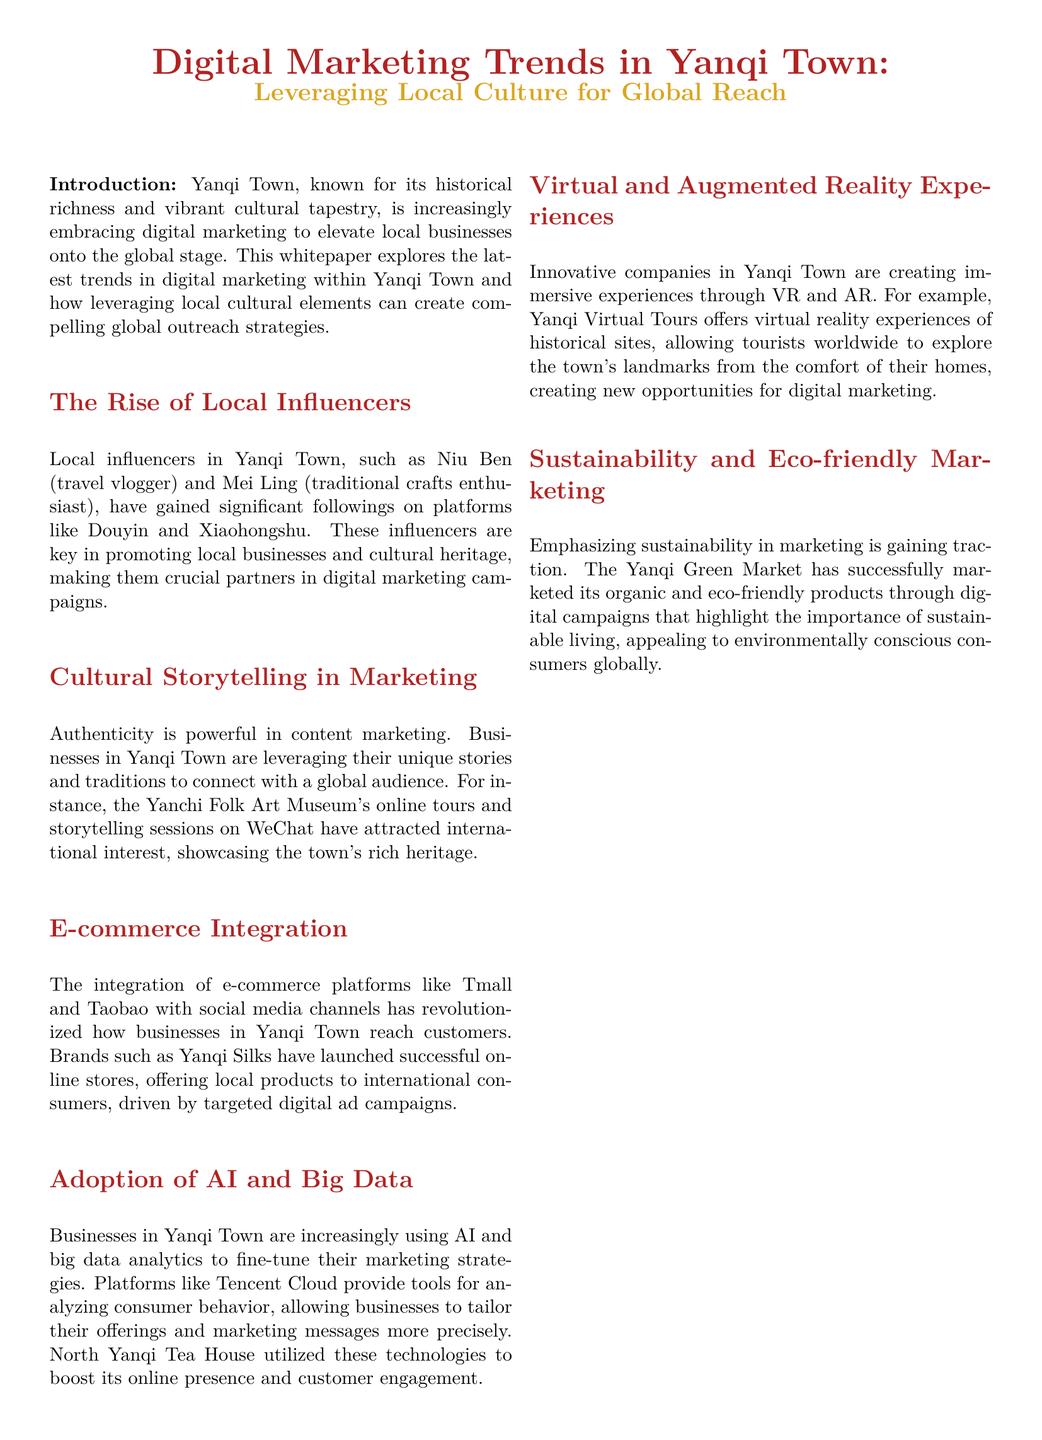What is the title of the document? The title is stated in a prominent manner at the beginning of the document.
Answer: Digital Marketing Trends in Yanqi Town: Leveraging Local Culture for Global Reach Who is an example of a local influencer mentioned? The document provides specific names of local influencers that promote Yanqi Town's culture.
Answer: Niu Ben What platforms are used by local influencers in Yanqi Town? The document lists specific social media platforms where local influencers are active.
Answer: Douyin and Xiaohongshu What kind of online experience does the Yanchi Folk Art Museum offer? The document describes a specific service provided by the Yanchi Folk Art Museum to attract international interest.
Answer: Online tours and storytelling sessions Which e-commerce platforms are mentioned in the document? The document specifies the e-commerce platforms that businesses in Yanqi Town are utilizing.
Answer: Tmall and Taobao What innovative technologies are businesses in Yanqi Town adopting? The document mentions specific technologies that businesses are integrating into their marketing strategies.
Answer: AI and big data What type of marketing is gaining traction in Yanqi Town according to the document? The document highlights a specific trend that reflects the current consumer interests and values.
Answer: Sustainability What is a unique digital marketing opportunity offered by Yanqi Virtual Tours? The document describes a specific service provided by Yanqi Virtual Tours that enhances digital marketing.
Answer: Virtual reality experiences What is the purpose of the Yanqi Green Market's digital campaigns? The document outlines the goals of the marketing efforts of the Yanqi Green Market.
Answer: Highlight the importance of sustainable living 